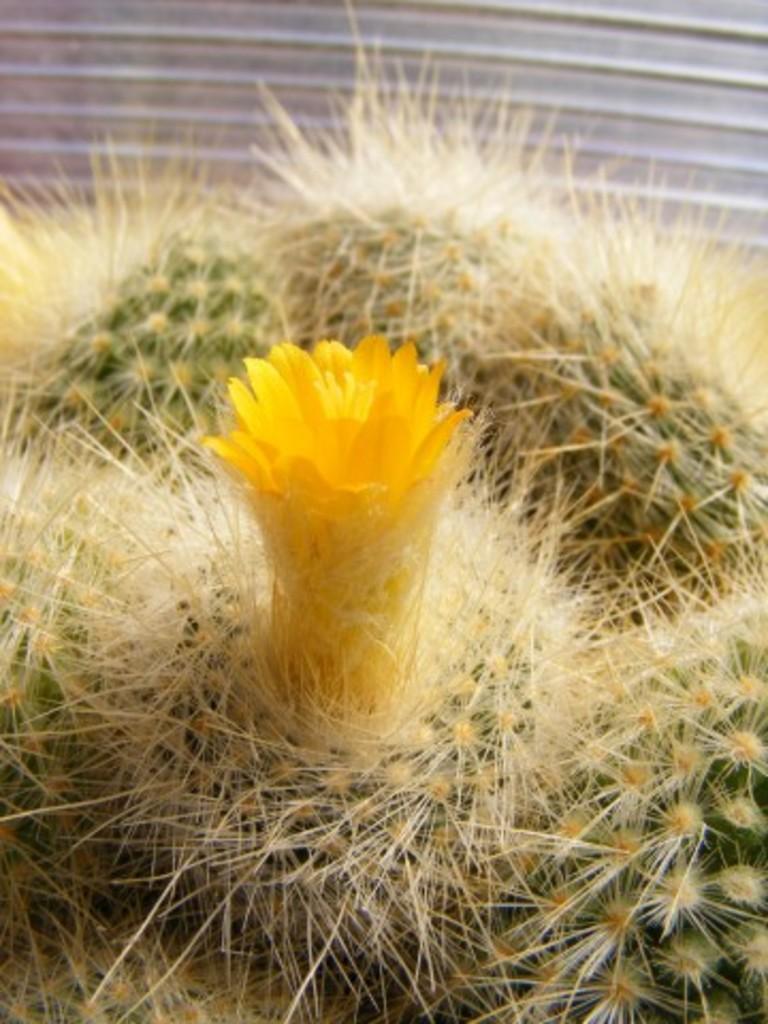Please provide a concise description of this image. As we can see in the image there is a plant and yellow color flower. 